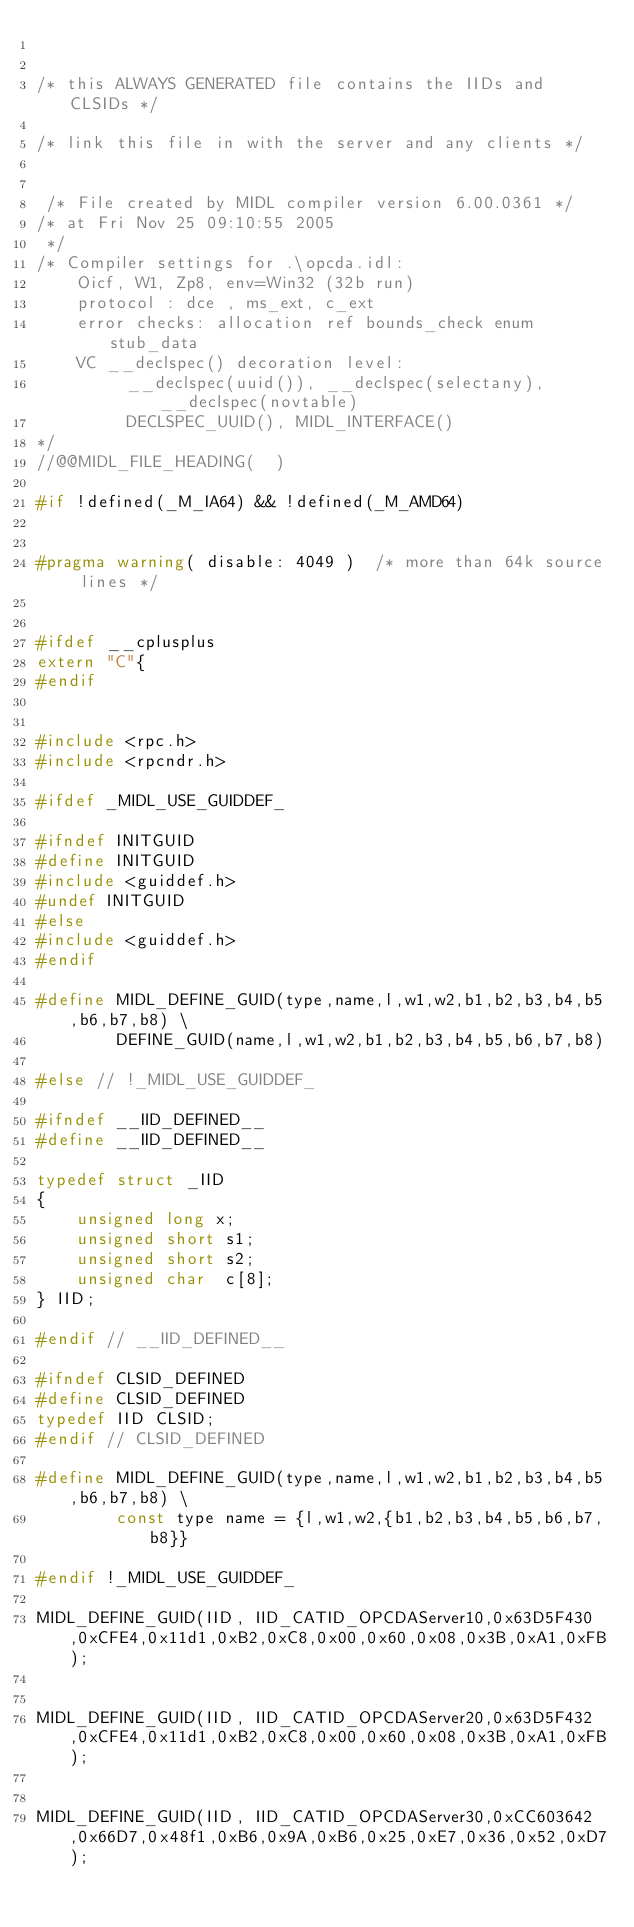Convert code to text. <code><loc_0><loc_0><loc_500><loc_500><_C_>

/* this ALWAYS GENERATED file contains the IIDs and CLSIDs */

/* link this file in with the server and any clients */


 /* File created by MIDL compiler version 6.00.0361 */
/* at Fri Nov 25 09:10:55 2005
 */
/* Compiler settings for .\opcda.idl:
    Oicf, W1, Zp8, env=Win32 (32b run)
    protocol : dce , ms_ext, c_ext
    error checks: allocation ref bounds_check enum stub_data 
    VC __declspec() decoration level: 
         __declspec(uuid()), __declspec(selectany), __declspec(novtable)
         DECLSPEC_UUID(), MIDL_INTERFACE()
*/
//@@MIDL_FILE_HEADING(  )

#if !defined(_M_IA64) && !defined(_M_AMD64)


#pragma warning( disable: 4049 )  /* more than 64k source lines */


#ifdef __cplusplus
extern "C"{
#endif 


#include <rpc.h>
#include <rpcndr.h>

#ifdef _MIDL_USE_GUIDDEF_

#ifndef INITGUID
#define INITGUID
#include <guiddef.h>
#undef INITGUID
#else
#include <guiddef.h>
#endif

#define MIDL_DEFINE_GUID(type,name,l,w1,w2,b1,b2,b3,b4,b5,b6,b7,b8) \
        DEFINE_GUID(name,l,w1,w2,b1,b2,b3,b4,b5,b6,b7,b8)

#else // !_MIDL_USE_GUIDDEF_

#ifndef __IID_DEFINED__
#define __IID_DEFINED__

typedef struct _IID
{
    unsigned long x;
    unsigned short s1;
    unsigned short s2;
    unsigned char  c[8];
} IID;

#endif // __IID_DEFINED__

#ifndef CLSID_DEFINED
#define CLSID_DEFINED
typedef IID CLSID;
#endif // CLSID_DEFINED

#define MIDL_DEFINE_GUID(type,name,l,w1,w2,b1,b2,b3,b4,b5,b6,b7,b8) \
        const type name = {l,w1,w2,{b1,b2,b3,b4,b5,b6,b7,b8}}

#endif !_MIDL_USE_GUIDDEF_

MIDL_DEFINE_GUID(IID, IID_CATID_OPCDAServer10,0x63D5F430,0xCFE4,0x11d1,0xB2,0xC8,0x00,0x60,0x08,0x3B,0xA1,0xFB);


MIDL_DEFINE_GUID(IID, IID_CATID_OPCDAServer20,0x63D5F432,0xCFE4,0x11d1,0xB2,0xC8,0x00,0x60,0x08,0x3B,0xA1,0xFB);


MIDL_DEFINE_GUID(IID, IID_CATID_OPCDAServer30,0xCC603642,0x66D7,0x48f1,0xB6,0x9A,0xB6,0x25,0xE7,0x36,0x52,0xD7);

</code> 